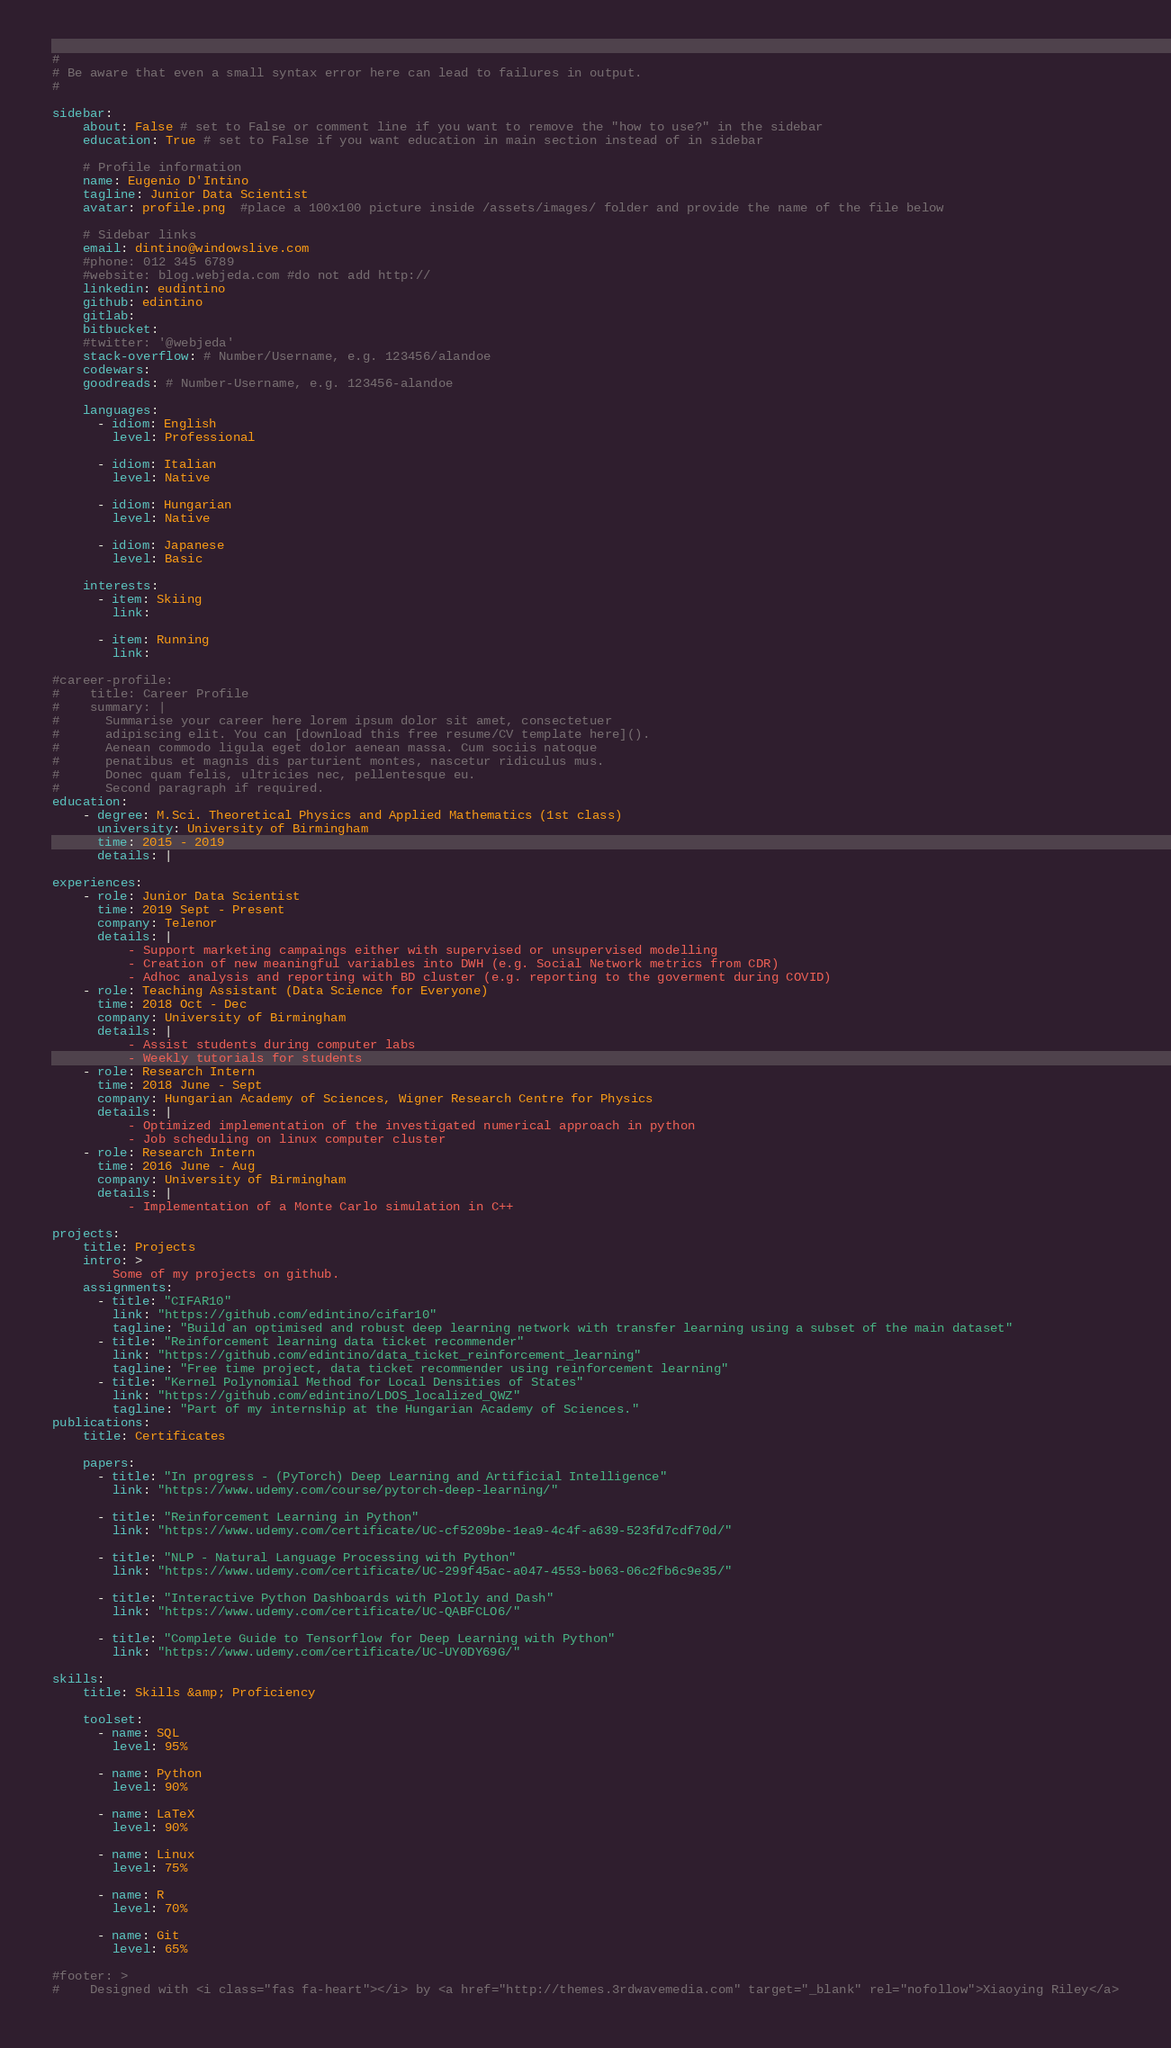Convert code to text. <code><loc_0><loc_0><loc_500><loc_500><_YAML_>#
# Be aware that even a small syntax error here can lead to failures in output.
#

sidebar:
    about: False # set to False or comment line if you want to remove the "how to use?" in the sidebar
    education: True # set to False if you want education in main section instead of in sidebar

    # Profile information
    name: Eugenio D'Intino
    tagline: Junior Data Scientist
    avatar: profile.png  #place a 100x100 picture inside /assets/images/ folder and provide the name of the file below

    # Sidebar links
    email: dintino@windowslive.com
    #phone: 012 345 6789
    #website: blog.webjeda.com #do not add http://
    linkedin: eudintino
    github: edintino
    gitlab:
    bitbucket:
    #twitter: '@webjeda'
    stack-overflow: # Number/Username, e.g. 123456/alandoe
    codewars:
    goodreads: # Number-Username, e.g. 123456-alandoe

    languages:
      - idiom: English
        level: Professional

      - idiom: Italian
        level: Native

      - idiom: Hungarian
        level: Native
      
      - idiom: Japanese
        level: Basic

    interests:
      - item: Skiing
        link:

      - item: Running
        link:

#career-profile:
#    title: Career Profile
#    summary: |
#      Summarise your career here lorem ipsum dolor sit amet, consectetuer
#      adipiscing elit. You can [download this free resume/CV template here]().
#      Aenean commodo ligula eget dolor aenean massa. Cum sociis natoque
#      penatibus et magnis dis parturient montes, nascetur ridiculus mus.
#      Donec quam felis, ultricies nec, pellentesque eu.
#      Second paragraph if required.
education:
    - degree: M.Sci. Theoretical Physics and Applied Mathematics (1st class)
      university: University of Birmingham
      time: 2015 - 2019
      details: |

experiences:
    - role: Junior Data Scientist
      time: 2019 Sept - Present
      company: Telenor
      details: |
          - Support marketing campaings either with supervised or unsupervised modelling
          - Creation of new meaningful variables into DWH (e.g. Social Network metrics from CDR)
          - Adhoc analysis and reporting with BD cluster (e.g. reporting to the goverment during COVID)
    - role: Teaching Assistant (Data Science for Everyone)
      time: 2018 Oct - Dec
      company: University of Birmingham
      details: |
          - Assist students during computer labs
          - Weekly tutorials for students
    - role: Research Intern
      time: 2018 June - Sept
      company: Hungarian Academy of Sciences, Wigner Research Centre for Physics
      details: |
          - Optimized implementation of the investigated numerical approach in python
          - Job scheduling on linux computer cluster
    - role: Research Intern
      time: 2016 June - Aug
      company: University of Birmingham
      details: |
          - Implementation of a Monte Carlo simulation in C++

projects:
    title: Projects
    intro: >
        Some of my projects on github.
    assignments:
      - title: "CIFAR10"
        link: "https://github.com/edintino/cifar10"
        tagline: "Build an optimised and robust deep learning network with transfer learning using a subset of the main dataset"
      - title: "Reinforcement learning data ticket recommender"
        link: "https://github.com/edintino/data_ticket_reinforcement_learning"
        tagline: "Free time project, data ticket recommender using reinforcement learning"
      - title: "Kernel Polynomial Method for Local Densities of States"
        link: "https://github.com/edintino/LDOS_localized_QWZ"
        tagline: "Part of my internship at the Hungarian Academy of Sciences."
publications:
    title: Certificates

    papers:
      - title: "In progress - (PyTorch) Deep Learning and Artificial Intelligence"
        link: "https://www.udemy.com/course/pytorch-deep-learning/"

      - title: "Reinforcement Learning in Python"
        link: "https://www.udemy.com/certificate/UC-cf5209be-1ea9-4c4f-a639-523fd7cdf70d/"

      - title: "NLP - Natural Language Processing with Python"
        link: "https://www.udemy.com/certificate/UC-299f45ac-a047-4553-b063-06c2fb6c9e35/"

      - title: "Interactive Python Dashboards with Plotly and Dash"
        link: "https://www.udemy.com/certificate/UC-QABFCLO6/"

      - title: "Complete Guide to Tensorflow for Deep Learning with Python"
        link: "https://www.udemy.com/certificate/UC-UY0DY69G/"

skills:
    title: Skills &amp; Proficiency

    toolset:
      - name: SQL
        level: 95%

      - name: Python 
        level: 90%

      - name: LaTeX
        level: 90%

      - name: Linux
        level: 75%

      - name: R
        level: 70%

      - name: Git
        level: 65%

#footer: >
#    Designed with <i class="fas fa-heart"></i> by <a href="http://themes.3rdwavemedia.com" target="_blank" rel="nofollow">Xiaoying Riley</a>
</code> 